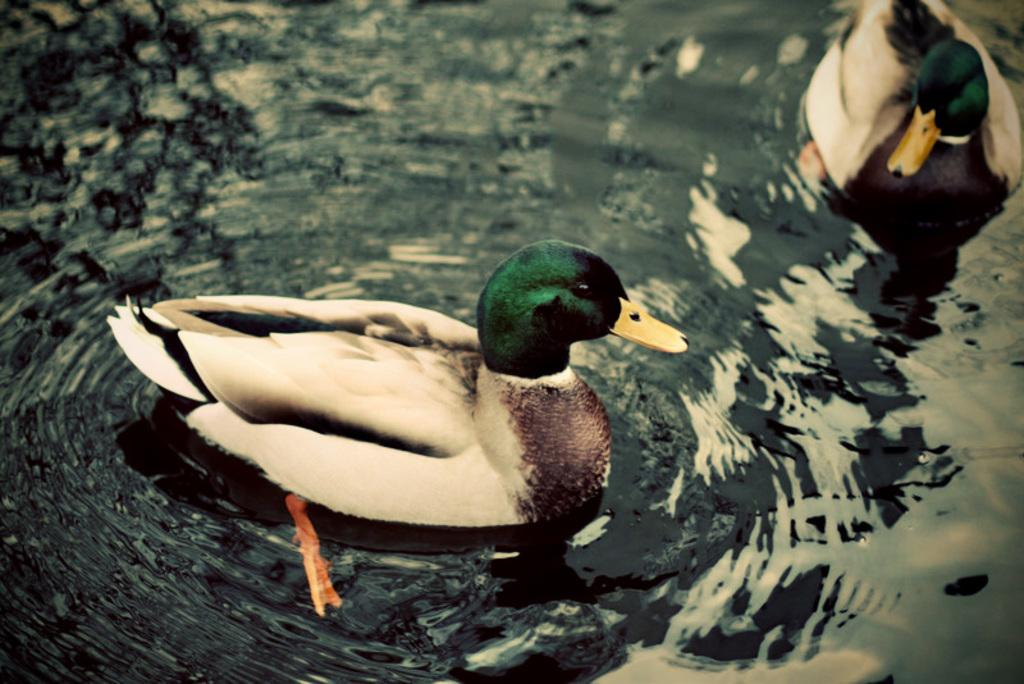Where was the picture taken? The picture was taken outside. What can be seen in the water body in the image? There are two ducks in the water body. What is the condition of the water in the image? There are ripples in the water body. What type of grain is being processed in the image? There is no grain or processing activity present in the image. 